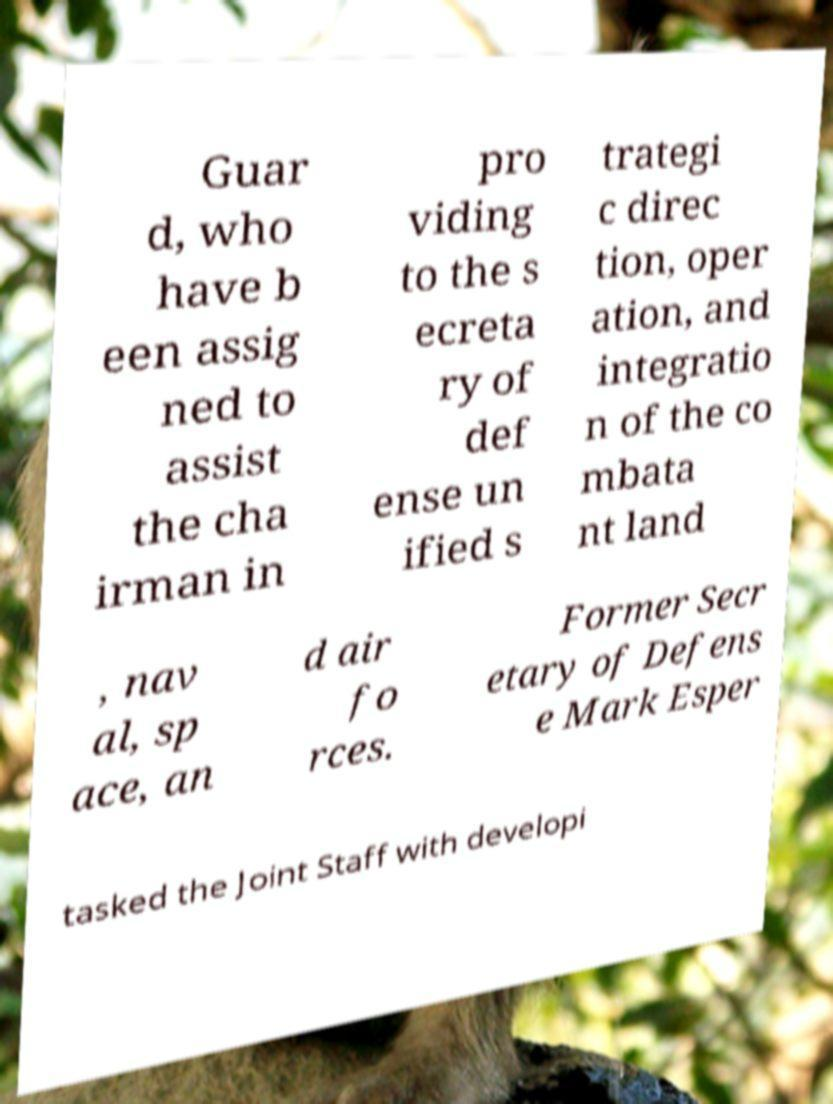For documentation purposes, I need the text within this image transcribed. Could you provide that? Guar d, who have b een assig ned to assist the cha irman in pro viding to the s ecreta ry of def ense un ified s trategi c direc tion, oper ation, and integratio n of the co mbata nt land , nav al, sp ace, an d air fo rces. Former Secr etary of Defens e Mark Esper tasked the Joint Staff with developi 